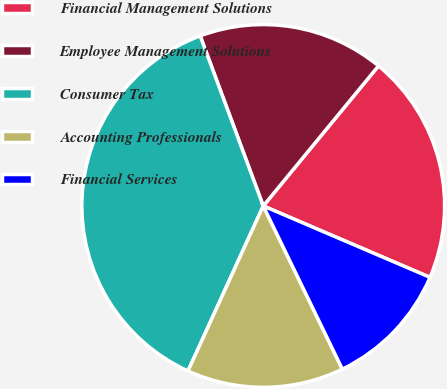Convert chart. <chart><loc_0><loc_0><loc_500><loc_500><pie_chart><fcel>Financial Management Solutions<fcel>Employee Management Solutions<fcel>Consumer Tax<fcel>Accounting Professionals<fcel>Financial Services<nl><fcel>20.48%<fcel>16.61%<fcel>37.54%<fcel>13.99%<fcel>11.38%<nl></chart> 